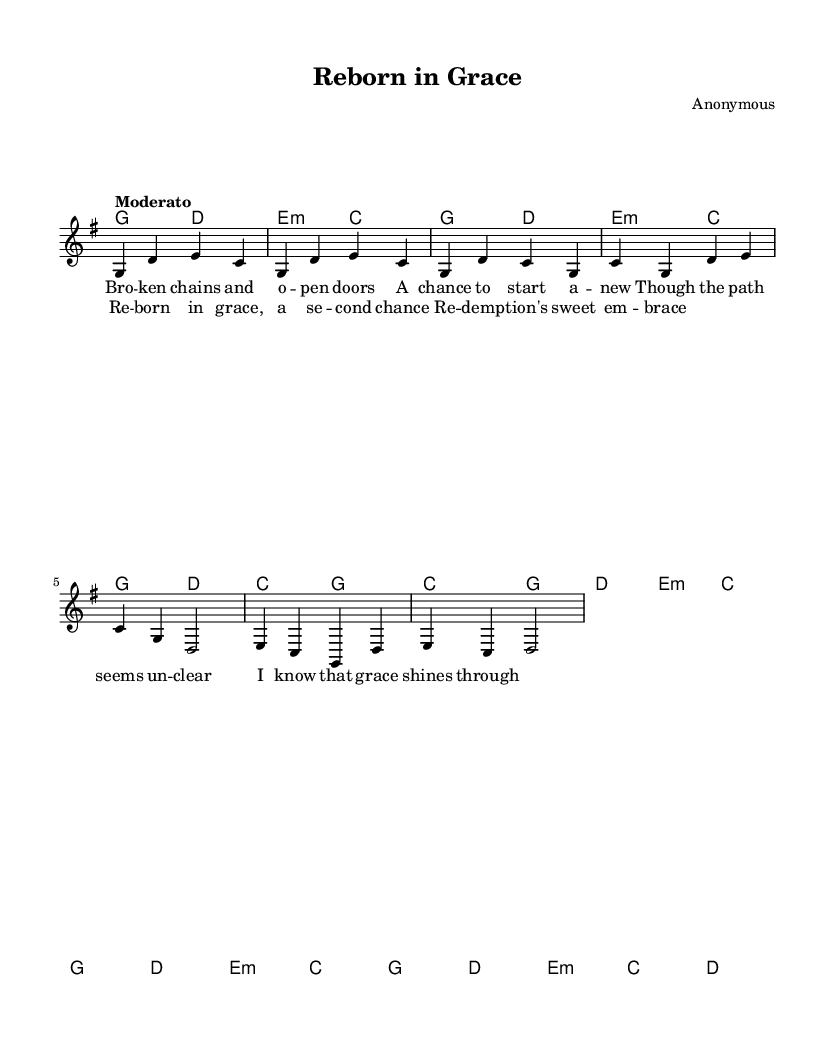What is the key signature of this music? The key signature is G major, which has one sharp (F#). This is determined by the clef and the number of sharps present in the key signature of the sheet music.
Answer: G major What is the time signature of this music? The time signature is 4/4, which means there are four beats in a measure and the quarter note gets one beat. This is found at the beginning of the music notation.
Answer: 4/4 What is the tempo marking of this piece? The tempo marking is "Moderato," indicating a moderate speed, usually ranging from 108 to 120 beats per minute. This marking is typically found at the beginning of the score.
Answer: Moderato How many verses are in the song? There is one verse in the sheet music, which is clearly indicated by the structure of the lyrics that follow a repeated melody for the verse.
Answer: One What is the main theme expressed in the lyrics? The main theme expressed in the lyrics is redemption, as it discusses broken chains, starting anew, and the embrace of redemption's grace. This is inferred from the content of the lyrics highlighted in the verse and chorus.
Answer: Redemption What musical elements are typically found in folk songs represented in this piece? The musical elements in this folk song include a simple melody, recurring themes of personal struggle, and a strong rhythmic feel, which are characteristic of folk music. This can be deduced from the straightforward structure and lyrical content present in the sheet music.
Answer: Simple melody, personal struggle 